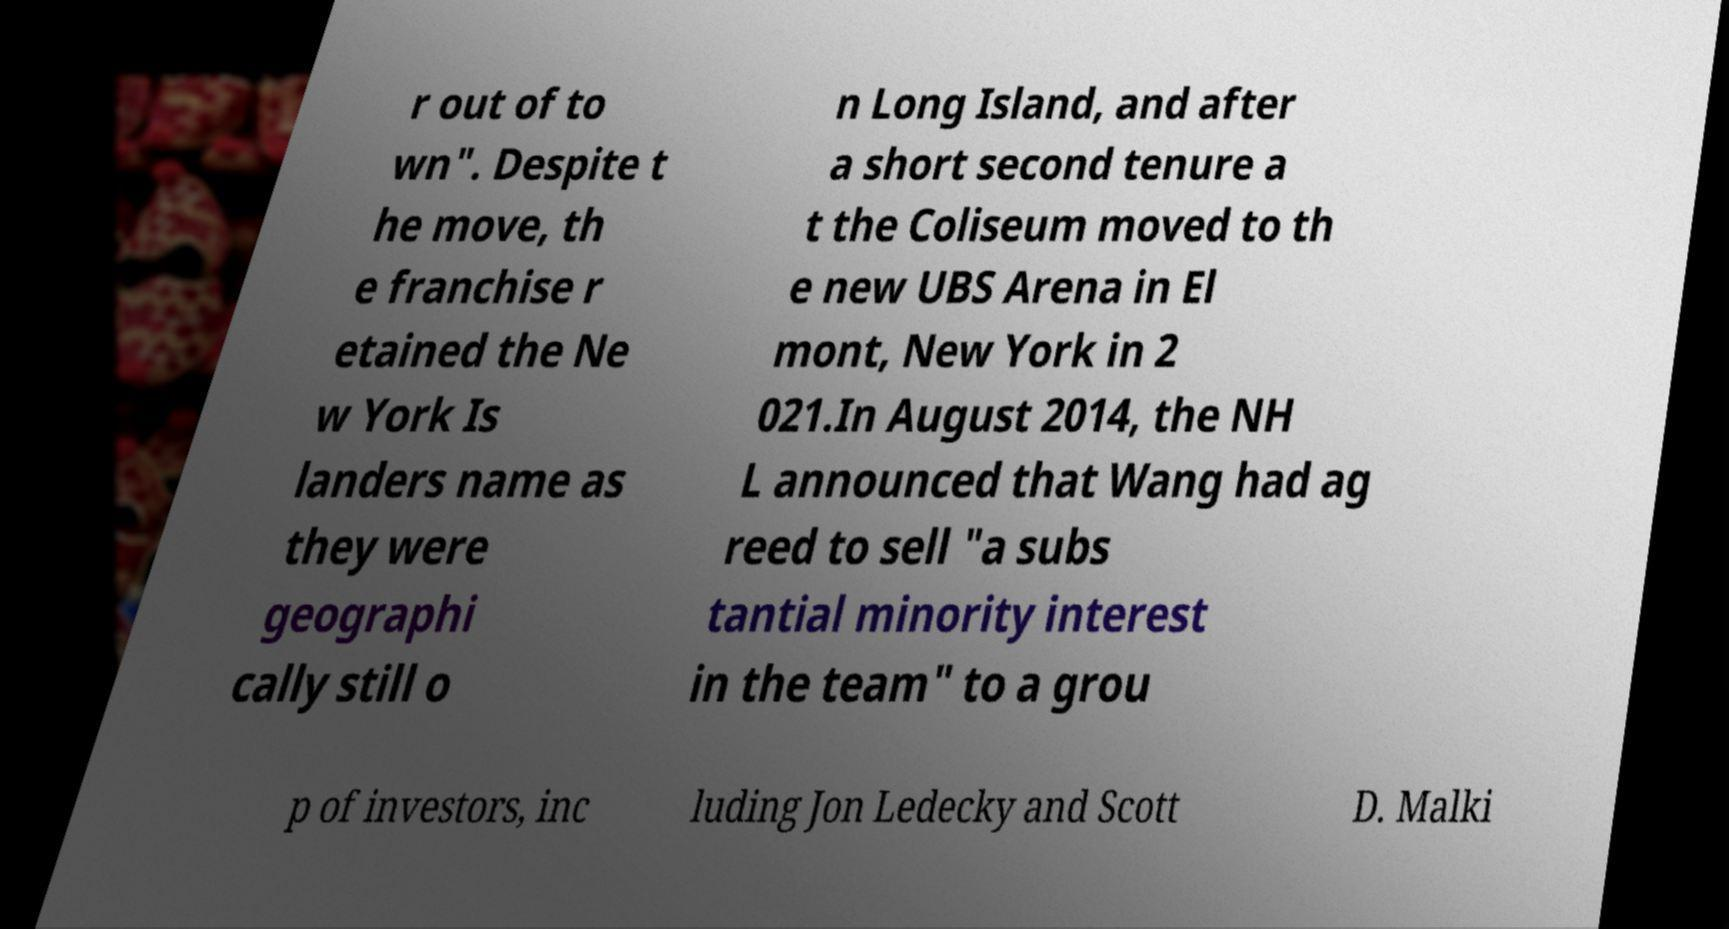Please identify and transcribe the text found in this image. r out of to wn". Despite t he move, th e franchise r etained the Ne w York Is landers name as they were geographi cally still o n Long Island, and after a short second tenure a t the Coliseum moved to th e new UBS Arena in El mont, New York in 2 021.In August 2014, the NH L announced that Wang had ag reed to sell "a subs tantial minority interest in the team" to a grou p of investors, inc luding Jon Ledecky and Scott D. Malki 